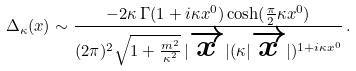Convert formula to latex. <formula><loc_0><loc_0><loc_500><loc_500>\Delta _ { \kappa } ( x ) \sim \frac { - 2 \kappa \, \Gamma ( 1 + i \kappa x ^ { 0 } ) \cosh ( \frac { \pi } { 2 } \kappa x ^ { 0 } ) } { ( 2 \pi ) ^ { 2 } \sqrt { 1 + \frac { m ^ { 2 } } { \kappa ^ { 2 } } } \, | \overrightarrow { x } | ( \kappa | \overrightarrow { x } | ) ^ { 1 + i \kappa x ^ { 0 } } } \, .</formula> 